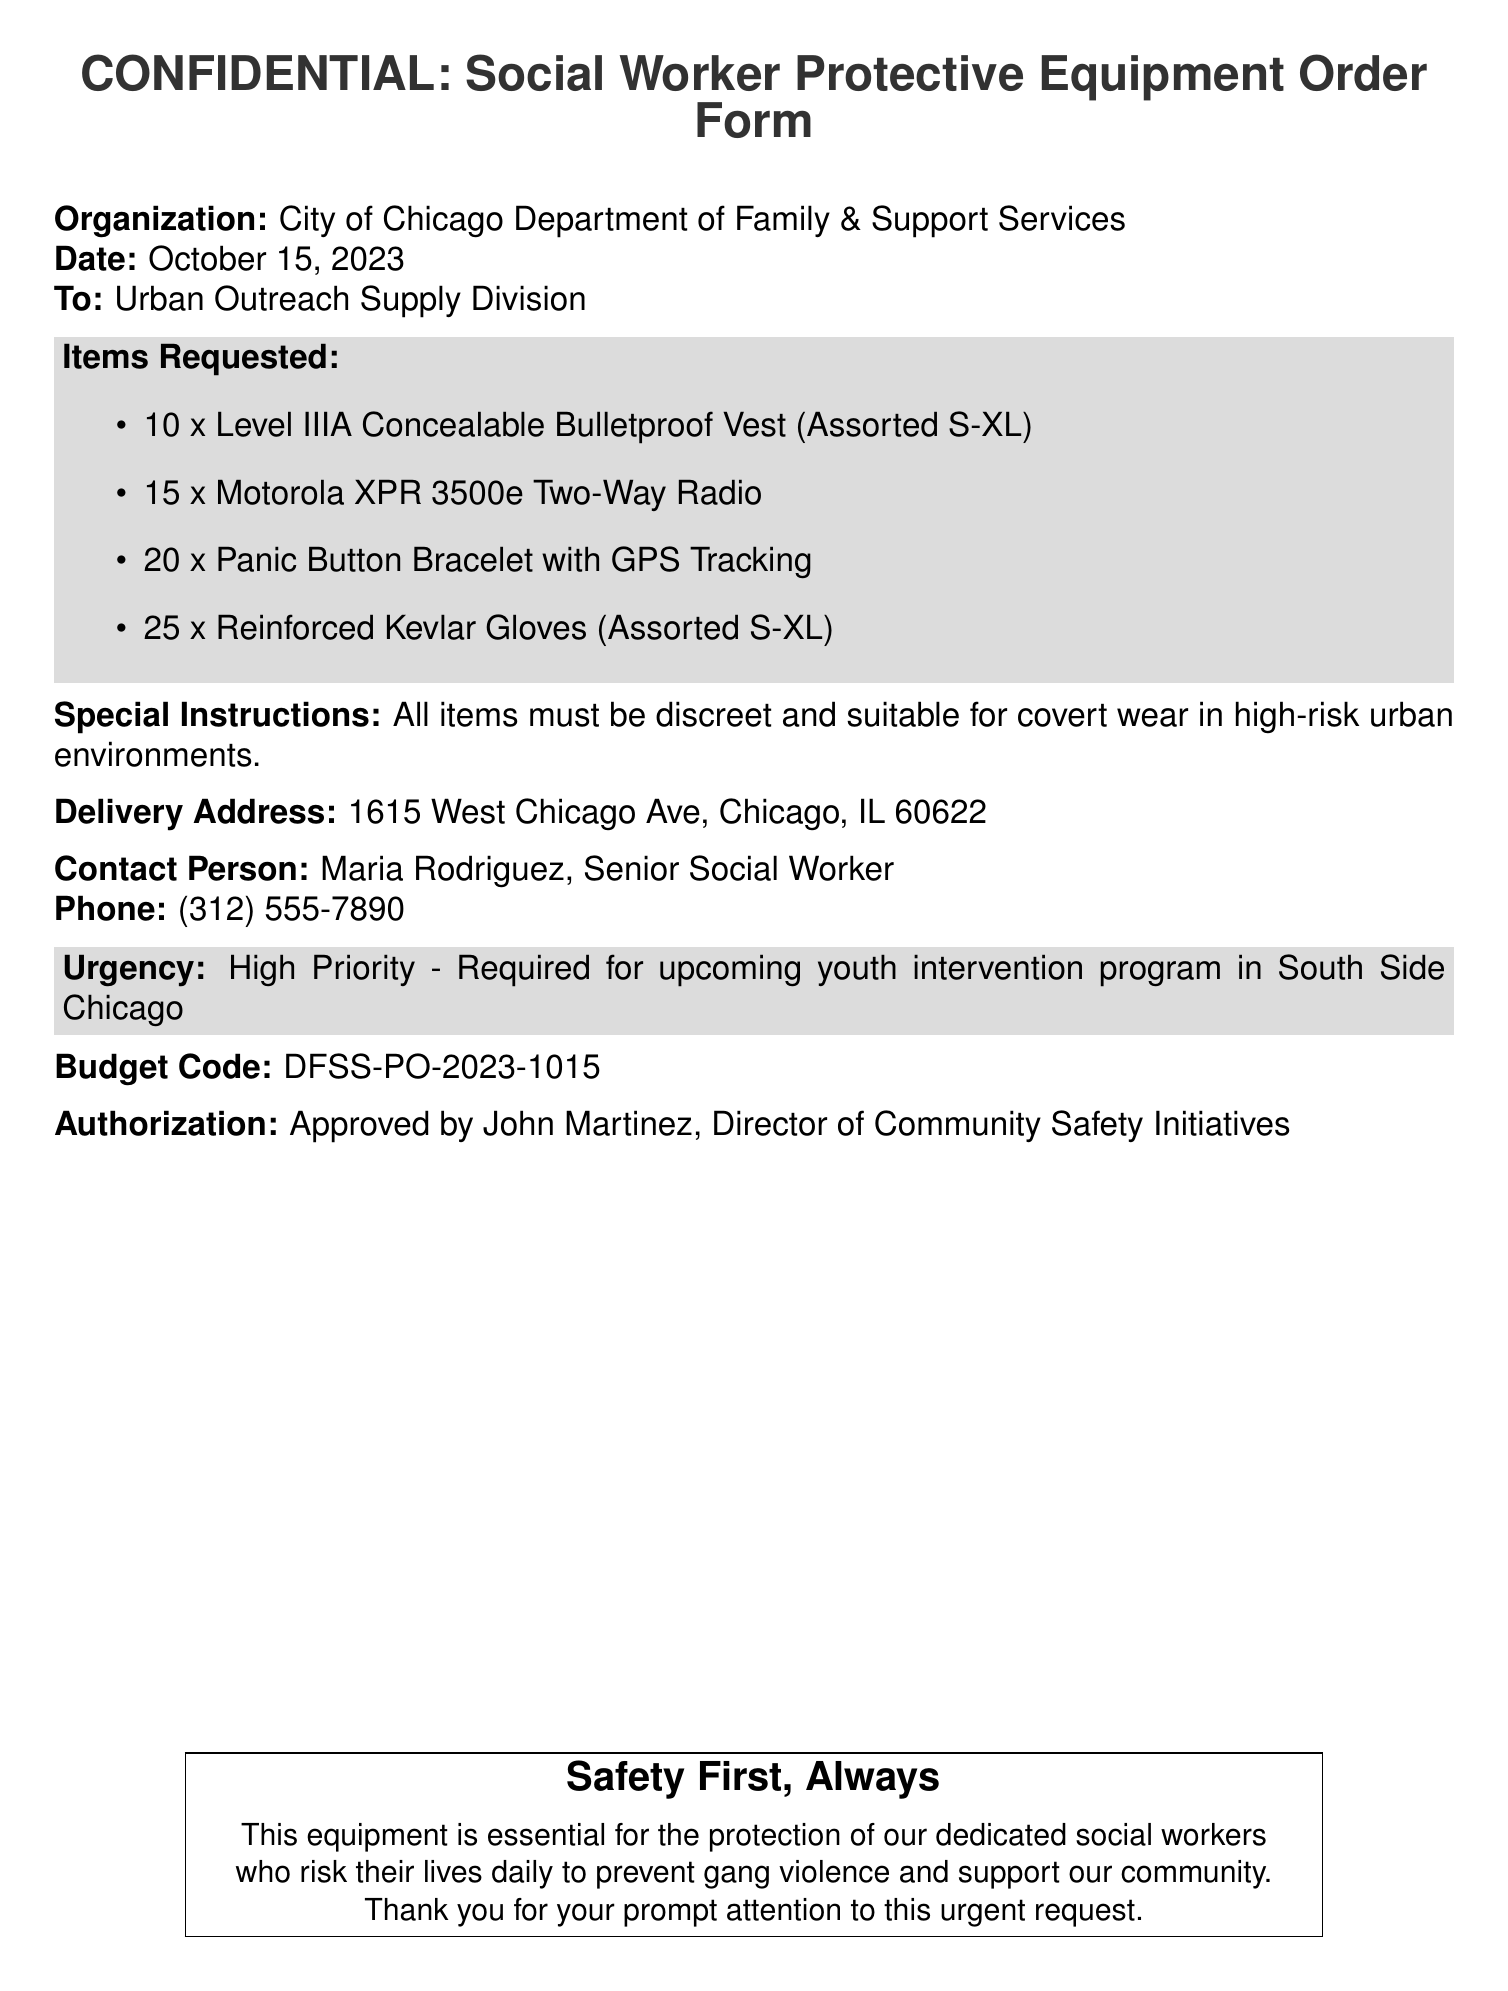What is the organization requesting the equipment? The organization is specified in the document as the City of Chicago Department of Family & Support Services.
Answer: City of Chicago Department of Family & Support Services Who is the contact person for the order? The document clearly states the contact person responsible for this order as Maria Rodriguez.
Answer: Maria Rodriguez How many bulletproof vests are being requested? The document lists a specific quantity of bulletproof vests requested, which is 10.
Answer: 10 What is the urgency level for the order? The urgency of the order is clearly labeled in the document as High Priority.
Answer: High Priority What is the delivery address for the equipment? The delivery address is provided in the document for sending the equipment, which is 1615 West Chicago Ave, Chicago, IL 60622.
Answer: 1615 West Chicago Ave, Chicago, IL 60622 What type of gloves are requested? The document specifies the type of gloves requested, which are Reinforced Kevlar Gloves.
Answer: Reinforced Kevlar Gloves Who approved the order? The individual who approved the order is mentioned in the document as John Martinez.
Answer: John Martinez What is the budget code for this order? The budget code provided in the document for the equipment order is DFSS-PO-2023-1015.
Answer: DFSS-PO-2023-1015 